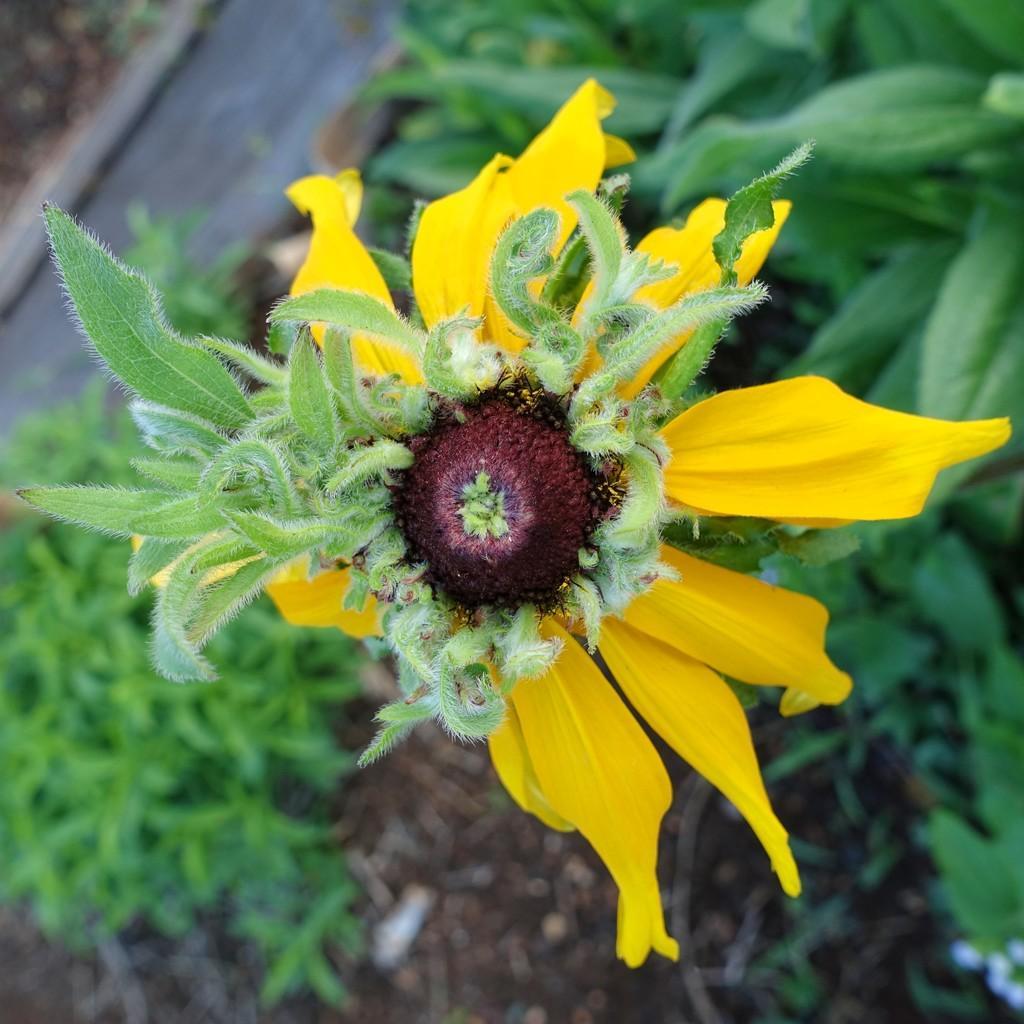In one or two sentences, can you explain what this image depicts? In the center of the image we can see a yellow color flower. In the background we can see the leaves and also the grass. 